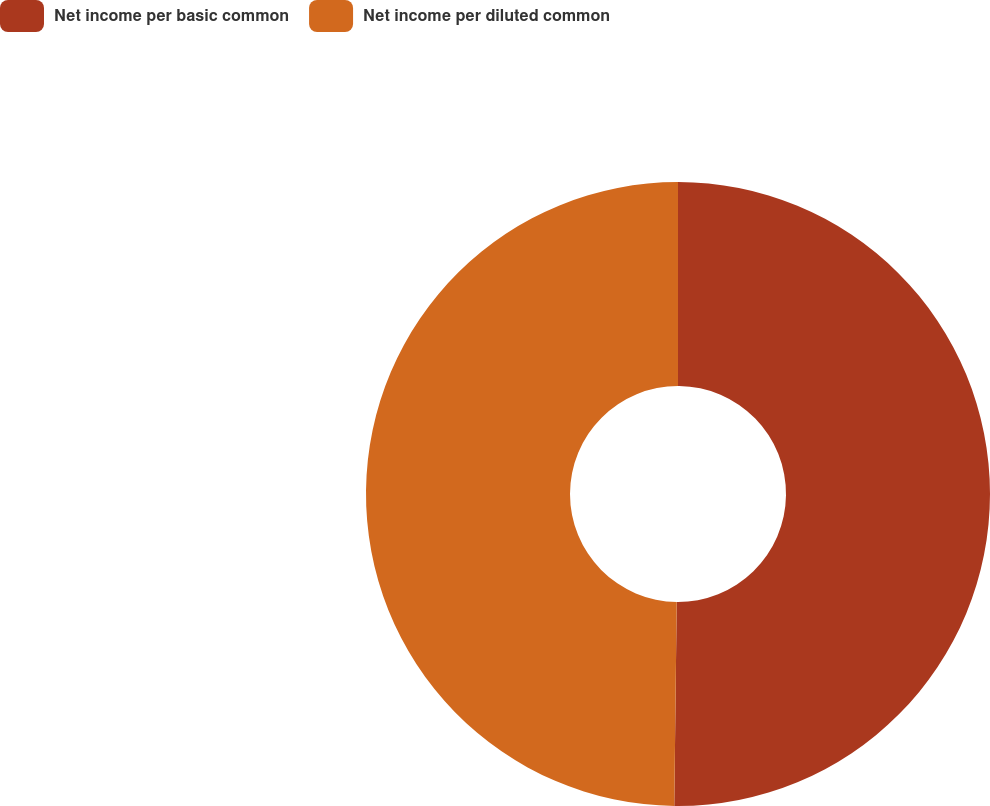Convert chart. <chart><loc_0><loc_0><loc_500><loc_500><pie_chart><fcel>Net income per basic common<fcel>Net income per diluted common<nl><fcel>50.19%<fcel>49.81%<nl></chart> 